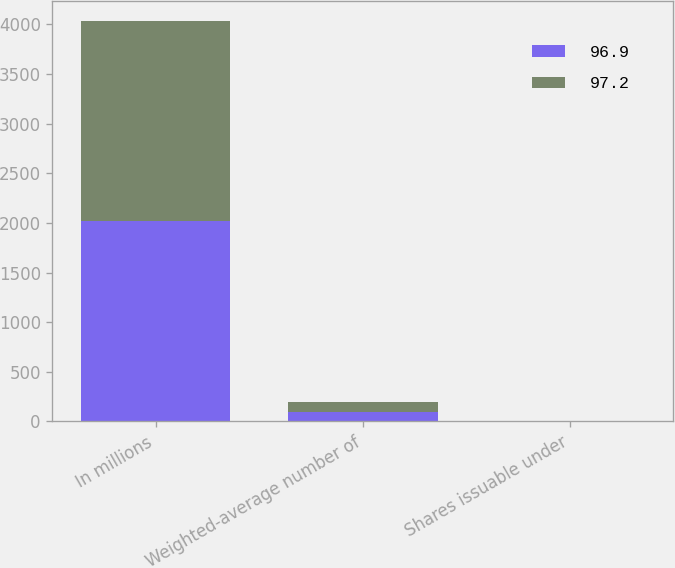Convert chart to OTSL. <chart><loc_0><loc_0><loc_500><loc_500><stacked_bar_chart><ecel><fcel>In millions<fcel>Weighted-average number of<fcel>Shares issuable under<nl><fcel>96.9<fcel>2016<fcel>96.9<fcel>1.1<nl><fcel>97.2<fcel>2014<fcel>97.2<fcel>1.1<nl></chart> 